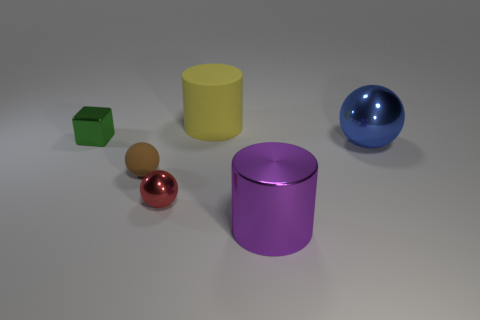Subtract all small red spheres. How many spheres are left? 2 Add 3 tiny green metal objects. How many objects exist? 9 Subtract all brown spheres. How many spheres are left? 2 Subtract all yellow cylinders. How many red balls are left? 1 Subtract all blocks. How many objects are left? 5 Subtract all brown balls. Subtract all gray cubes. How many balls are left? 2 Subtract all large yellow rubber cylinders. Subtract all metal blocks. How many objects are left? 4 Add 5 blue objects. How many blue objects are left? 6 Add 6 yellow metallic balls. How many yellow metallic balls exist? 6 Subtract 0 cyan blocks. How many objects are left? 6 